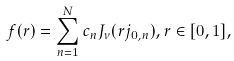Convert formula to latex. <formula><loc_0><loc_0><loc_500><loc_500>f ( r ) = \sum _ { n = 1 } ^ { N } c _ { n } J _ { \nu } ( r j _ { 0 , n } ) , r \in [ 0 , 1 ] ,</formula> 